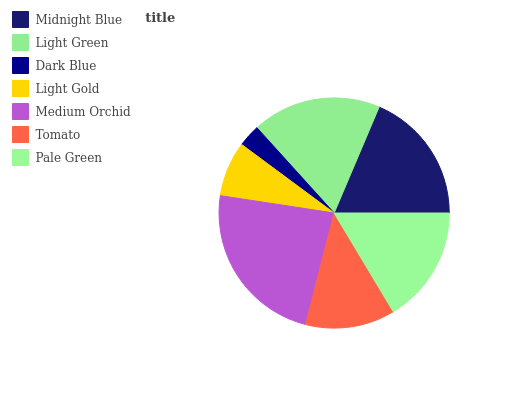Is Dark Blue the minimum?
Answer yes or no. Yes. Is Medium Orchid the maximum?
Answer yes or no. Yes. Is Light Green the minimum?
Answer yes or no. No. Is Light Green the maximum?
Answer yes or no. No. Is Midnight Blue greater than Light Green?
Answer yes or no. Yes. Is Light Green less than Midnight Blue?
Answer yes or no. Yes. Is Light Green greater than Midnight Blue?
Answer yes or no. No. Is Midnight Blue less than Light Green?
Answer yes or no. No. Is Pale Green the high median?
Answer yes or no. Yes. Is Pale Green the low median?
Answer yes or no. Yes. Is Tomato the high median?
Answer yes or no. No. Is Midnight Blue the low median?
Answer yes or no. No. 